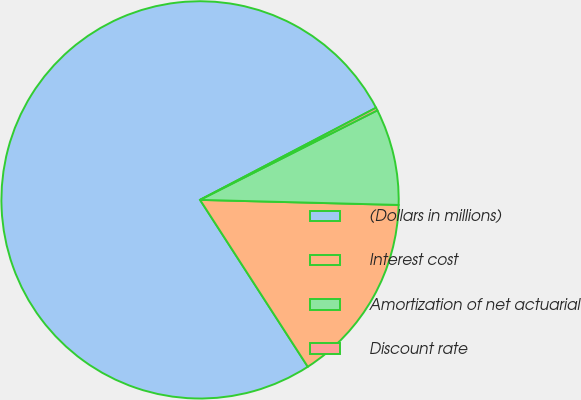<chart> <loc_0><loc_0><loc_500><loc_500><pie_chart><fcel>(Dollars in millions)<fcel>Interest cost<fcel>Amortization of net actuarial<fcel>Discount rate<nl><fcel>76.45%<fcel>15.47%<fcel>7.85%<fcel>0.23%<nl></chart> 